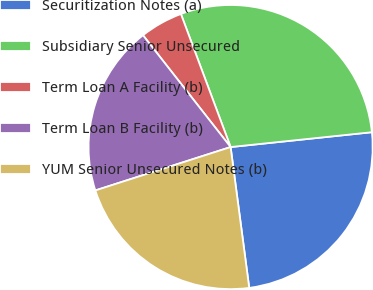Convert chart. <chart><loc_0><loc_0><loc_500><loc_500><pie_chart><fcel>Securitization Notes (a)<fcel>Subsidiary Senior Unsecured<fcel>Term Loan A Facility (b)<fcel>Term Loan B Facility (b)<fcel>YUM Senior Unsecured Notes (b)<nl><fcel>24.57%<fcel>29.02%<fcel>4.89%<fcel>19.36%<fcel>22.15%<nl></chart> 